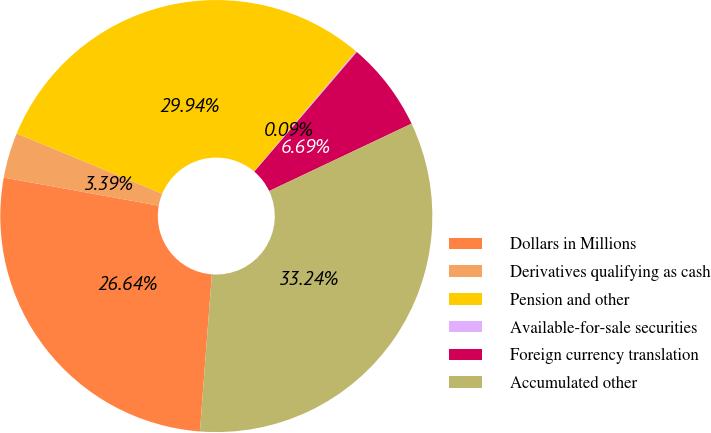<chart> <loc_0><loc_0><loc_500><loc_500><pie_chart><fcel>Dollars in Millions<fcel>Derivatives qualifying as cash<fcel>Pension and other<fcel>Available-for-sale securities<fcel>Foreign currency translation<fcel>Accumulated other<nl><fcel>26.64%<fcel>3.39%<fcel>29.94%<fcel>0.09%<fcel>6.69%<fcel>33.24%<nl></chart> 